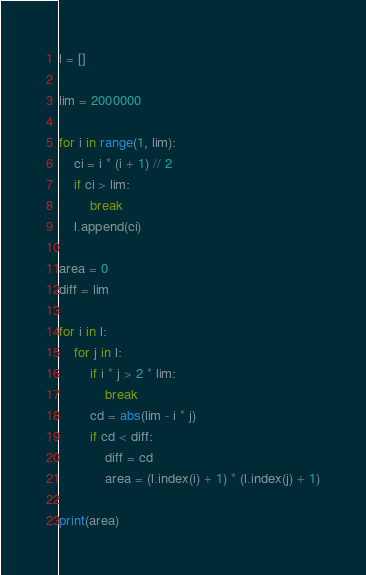<code> <loc_0><loc_0><loc_500><loc_500><_Python_>l = []

lim = 2000000

for i in range(1, lim):
    ci = i * (i + 1) // 2
    if ci > lim:
        break
    l.append(ci)

area = 0
diff = lim

for i in l:
    for j in l:
        if i * j > 2 * lim:
            break
        cd = abs(lim - i * j)
        if cd < diff:
            diff = cd
            area = (l.index(i) + 1) * (l.index(j) + 1)

print(area)</code> 